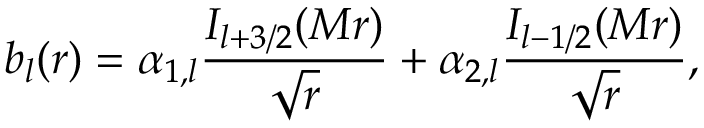<formula> <loc_0><loc_0><loc_500><loc_500>b _ { l } ( r ) = \alpha _ { 1 , l } { \frac { I _ { l + 3 / 2 } ( M r ) } { \sqrt { r } } } + \alpha _ { 2 , l } { \frac { I _ { l - 1 / 2 } ( M r ) } { \sqrt { r } } } ,</formula> 